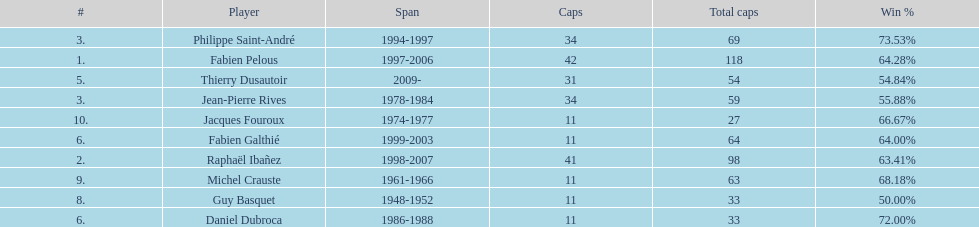How long did fabien pelous serve as captain in the french national rugby team? 9 years. 